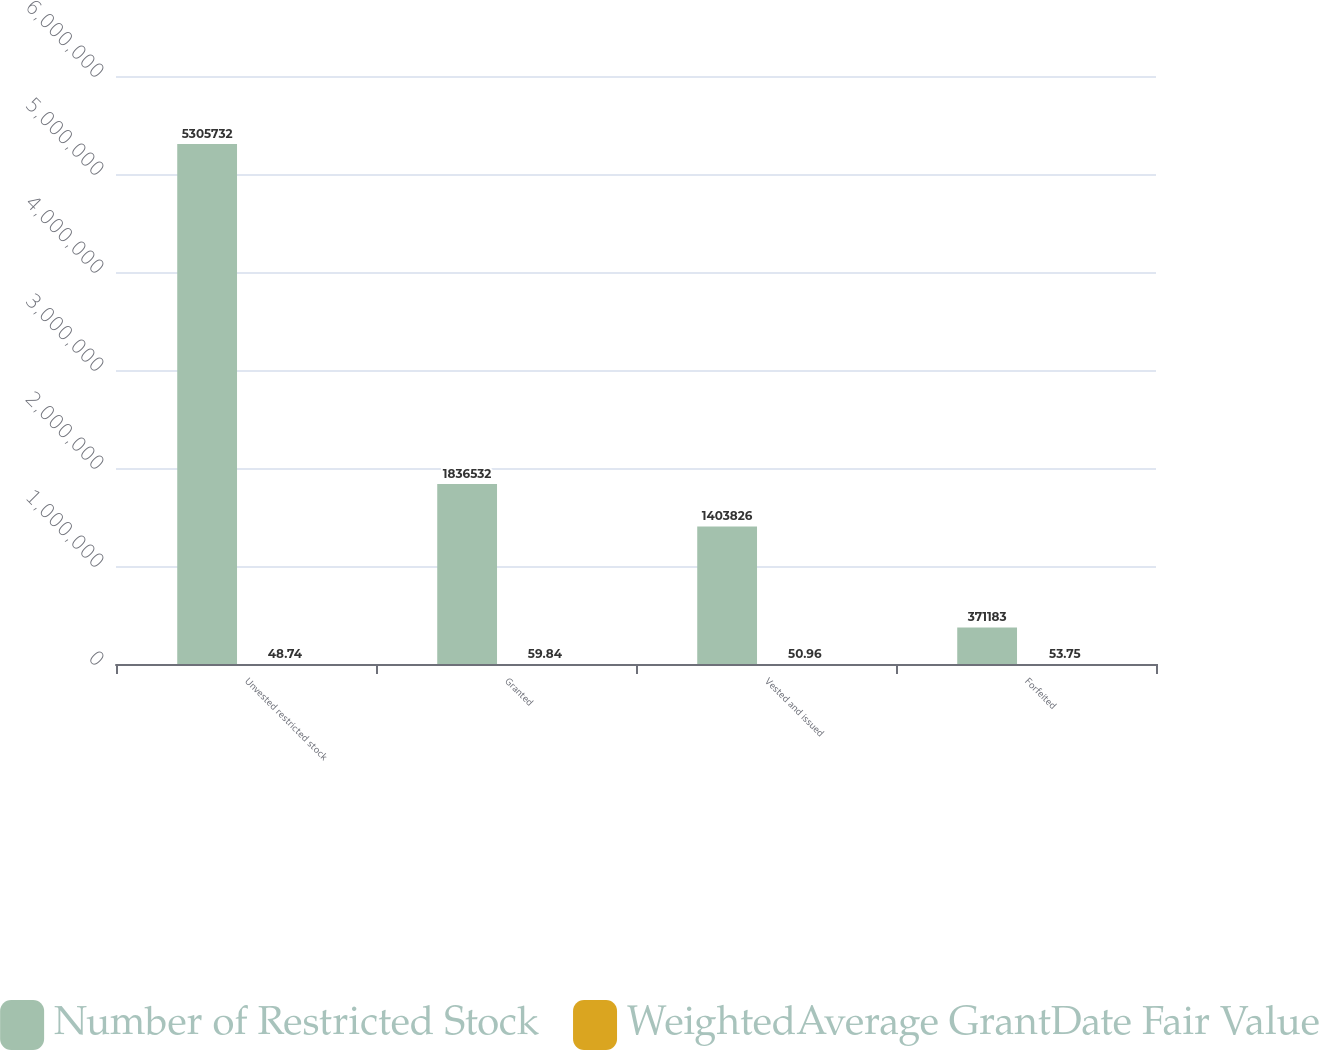Convert chart to OTSL. <chart><loc_0><loc_0><loc_500><loc_500><stacked_bar_chart><ecel><fcel>Unvested restricted stock<fcel>Granted<fcel>Vested and issued<fcel>Forfeited<nl><fcel>Number of Restricted Stock<fcel>5.30573e+06<fcel>1.83653e+06<fcel>1.40383e+06<fcel>371183<nl><fcel>WeightedAverage GrantDate Fair Value<fcel>48.74<fcel>59.84<fcel>50.96<fcel>53.75<nl></chart> 